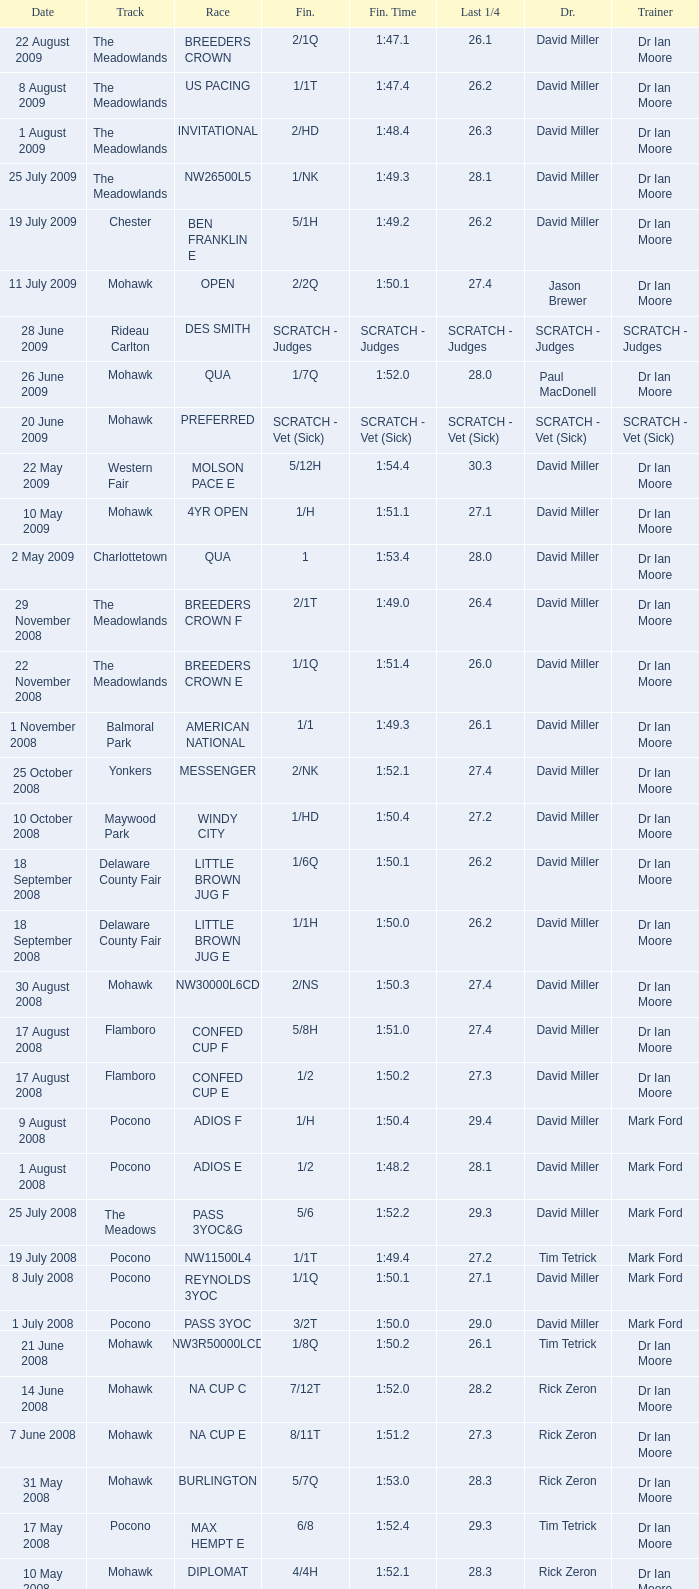What is the finishing time with a 2/1q finish on the Meadowlands track? 1:47.1. 